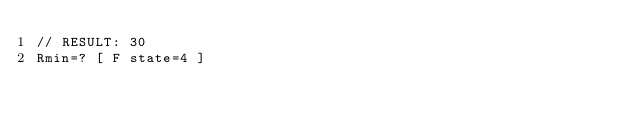Convert code to text. <code><loc_0><loc_0><loc_500><loc_500><_XML_>// RESULT: 30
Rmin=? [ F state=4 ]
</code> 